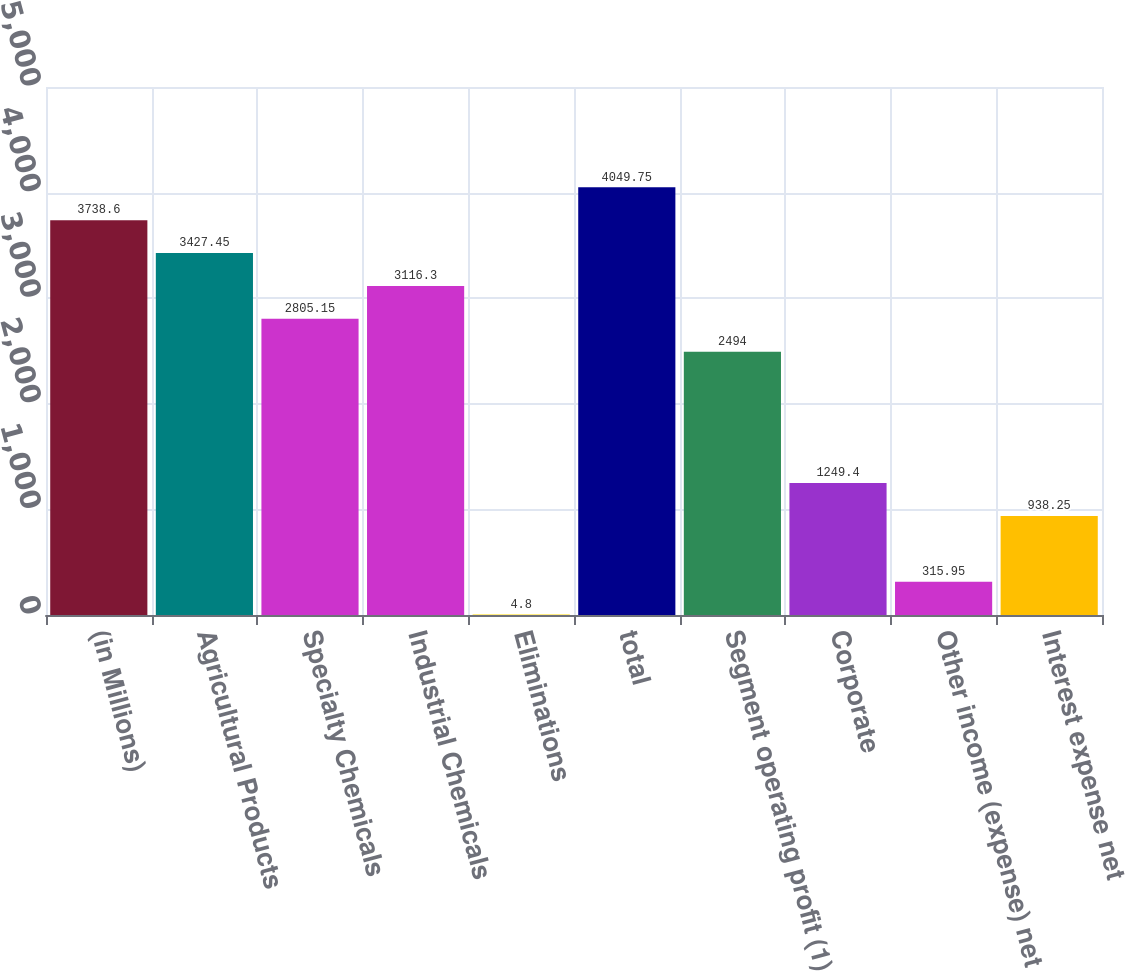Convert chart. <chart><loc_0><loc_0><loc_500><loc_500><bar_chart><fcel>(in Millions)<fcel>Agricultural Products<fcel>Specialty Chemicals<fcel>Industrial Chemicals<fcel>Eliminations<fcel>total<fcel>Segment operating profit (1)<fcel>Corporate<fcel>Other income (expense) net<fcel>Interest expense net<nl><fcel>3738.6<fcel>3427.45<fcel>2805.15<fcel>3116.3<fcel>4.8<fcel>4049.75<fcel>2494<fcel>1249.4<fcel>315.95<fcel>938.25<nl></chart> 